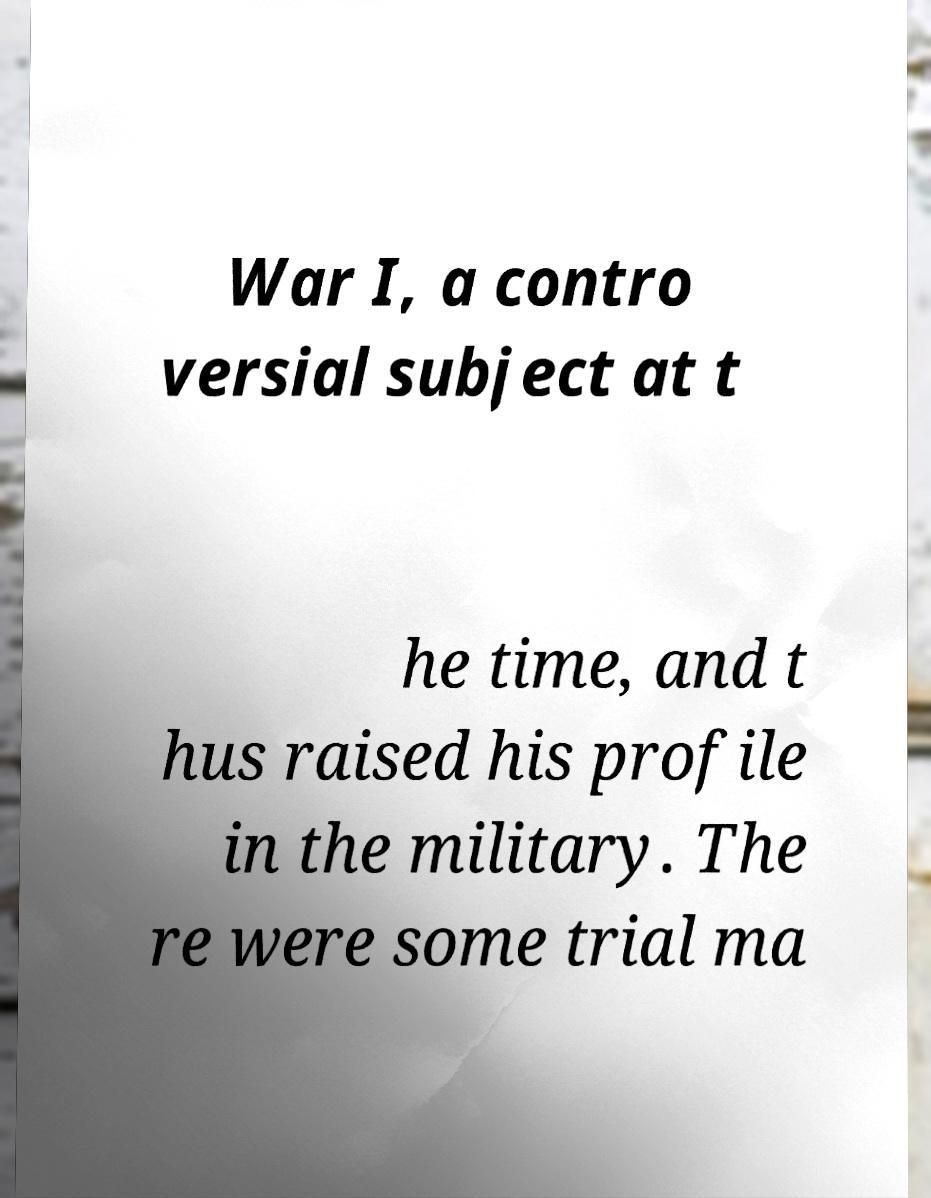Could you extract and type out the text from this image? War I, a contro versial subject at t he time, and t hus raised his profile in the military. The re were some trial ma 